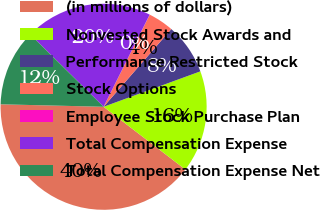Convert chart to OTSL. <chart><loc_0><loc_0><loc_500><loc_500><pie_chart><fcel>(in millions of dollars)<fcel>Nonvested Stock Awards and<fcel>Performance Restricted Stock<fcel>Stock Options<fcel>Employee Stock Purchase Plan<fcel>Total Compensation Expense<fcel>Total Compensation Expense Net<nl><fcel>39.96%<fcel>16.0%<fcel>8.01%<fcel>4.01%<fcel>0.02%<fcel>19.99%<fcel>12.0%<nl></chart> 